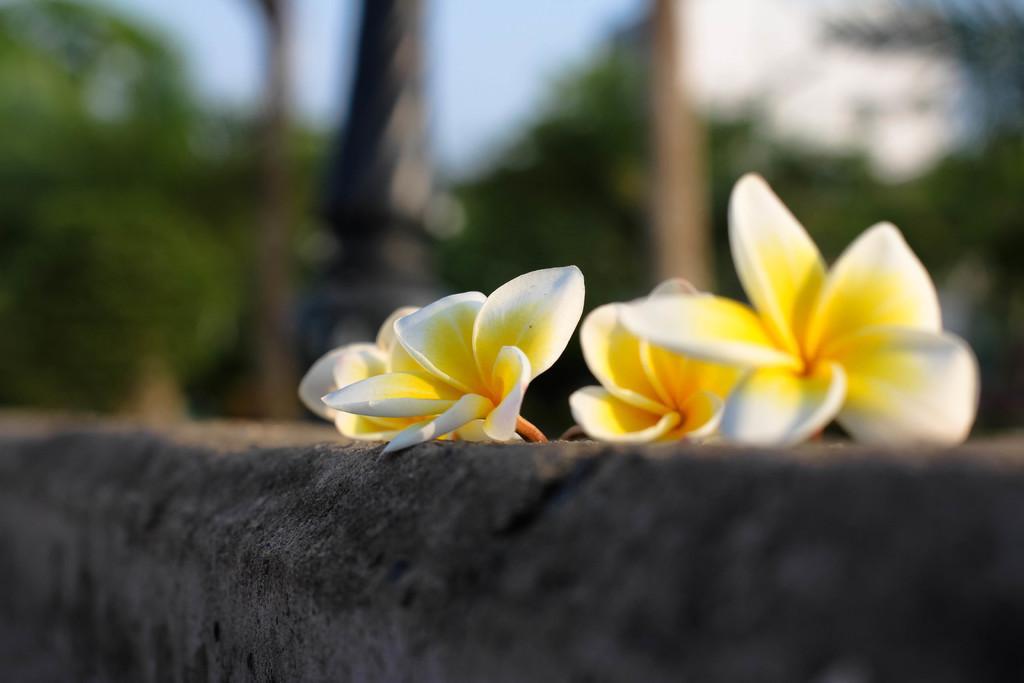How would you summarize this image in a sentence or two? Here in this picture we can see flowers present on a wall over there and behind it we can see poles and trees and plants, all present in a blurred manner. 